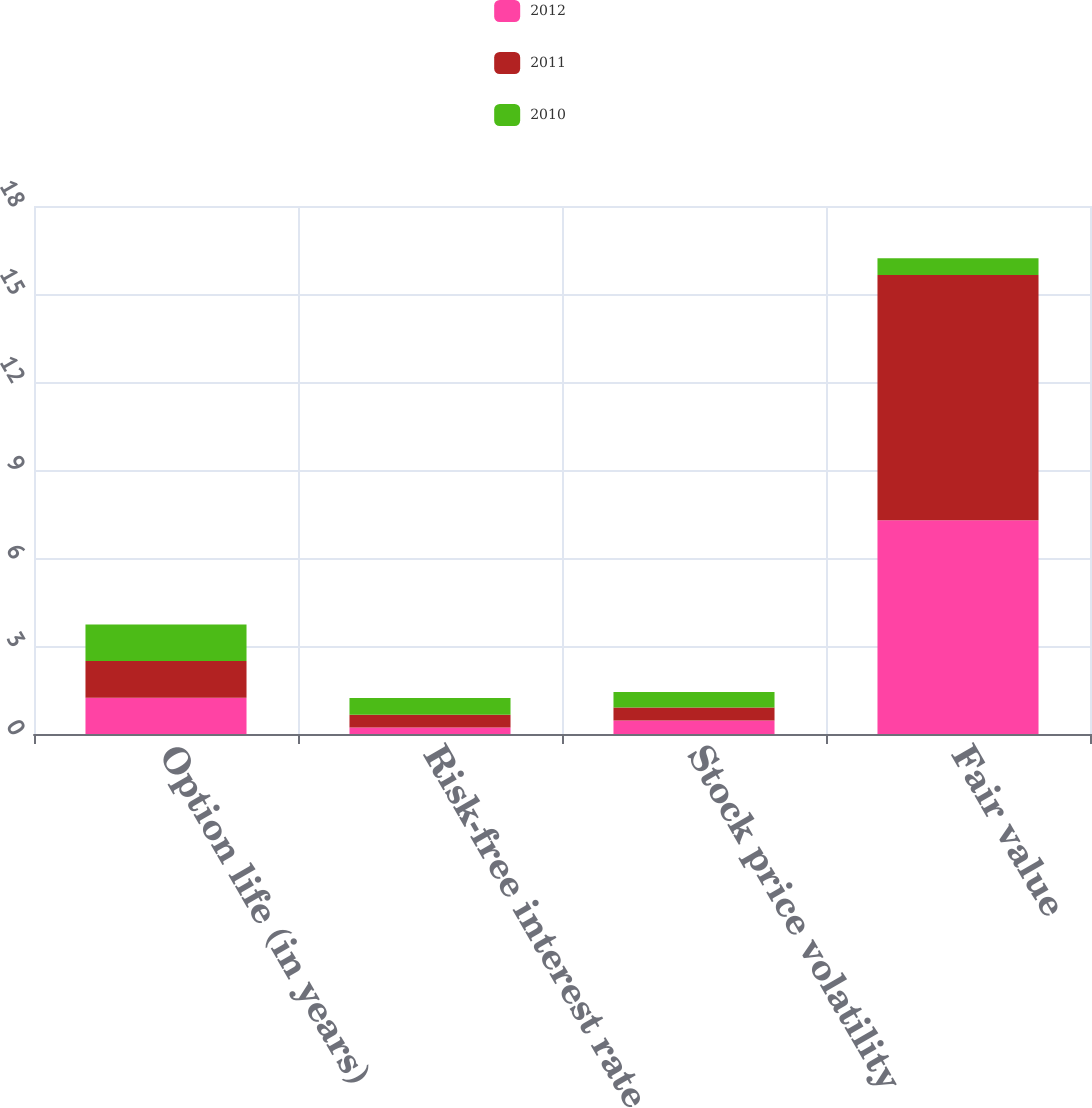Convert chart. <chart><loc_0><loc_0><loc_500><loc_500><stacked_bar_chart><ecel><fcel>Option life (in years)<fcel>Risk-free interest rate<fcel>Stock price volatility<fcel>Fair value<nl><fcel>2012<fcel>1.24<fcel>0.22<fcel>0.46<fcel>7.29<nl><fcel>2011<fcel>1.25<fcel>0.44<fcel>0.44<fcel>8.36<nl><fcel>2010<fcel>1.24<fcel>0.57<fcel>0.53<fcel>0.57<nl></chart> 